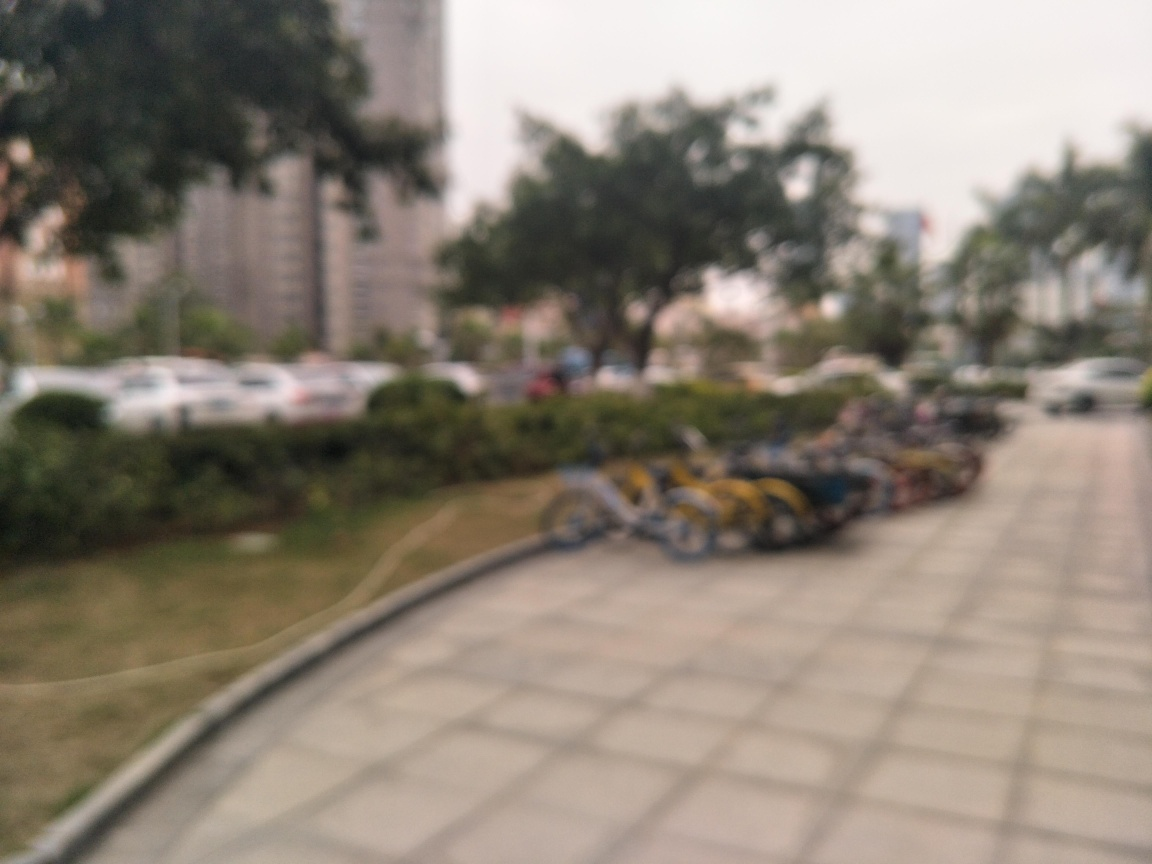What's the possible reason for the blurriness of this photo? The photo could be blurry due to several reasons: the camera might have been out of focus, the photographer could have moved the camera while the shutter was open, or it may be a result of a low-quality lens or sensor. Does the quality of the image affect its potential uses or interpretations? Absolutely, the blurriness limits the image's use for detailed analysis or identification of specific features. However, it may still evoke a general sense of the environment or mood, which could be suitable for abstract or artistic purposes. 